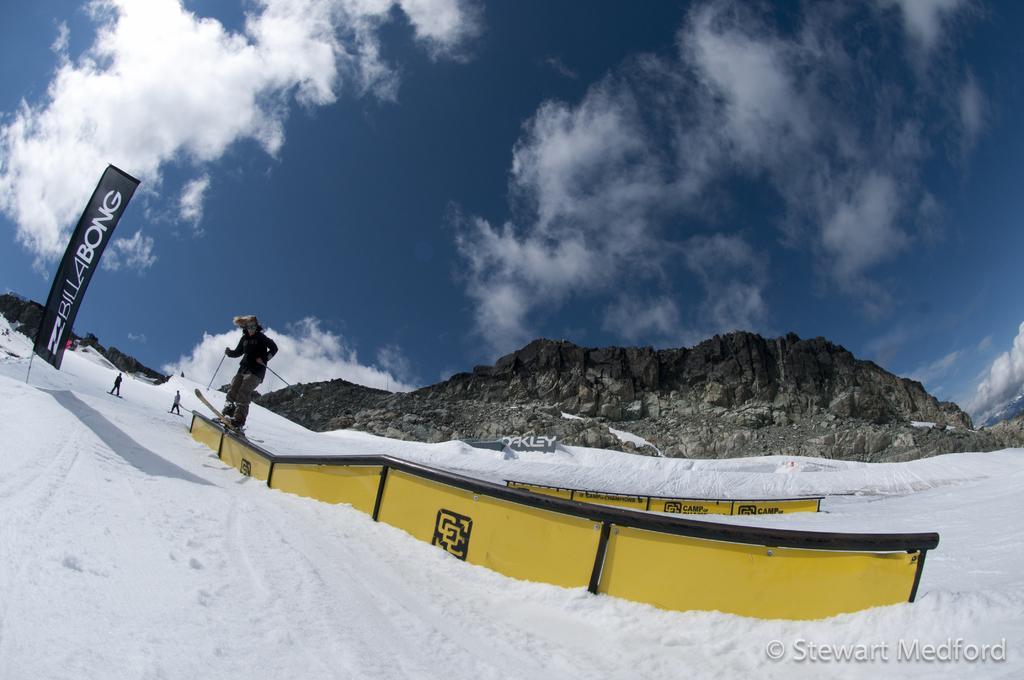How would you summarize this image in a sentence or two? In this image the person is standing on a ski board. At the back side there is a mountain sky and a cloud. There is a snow. 